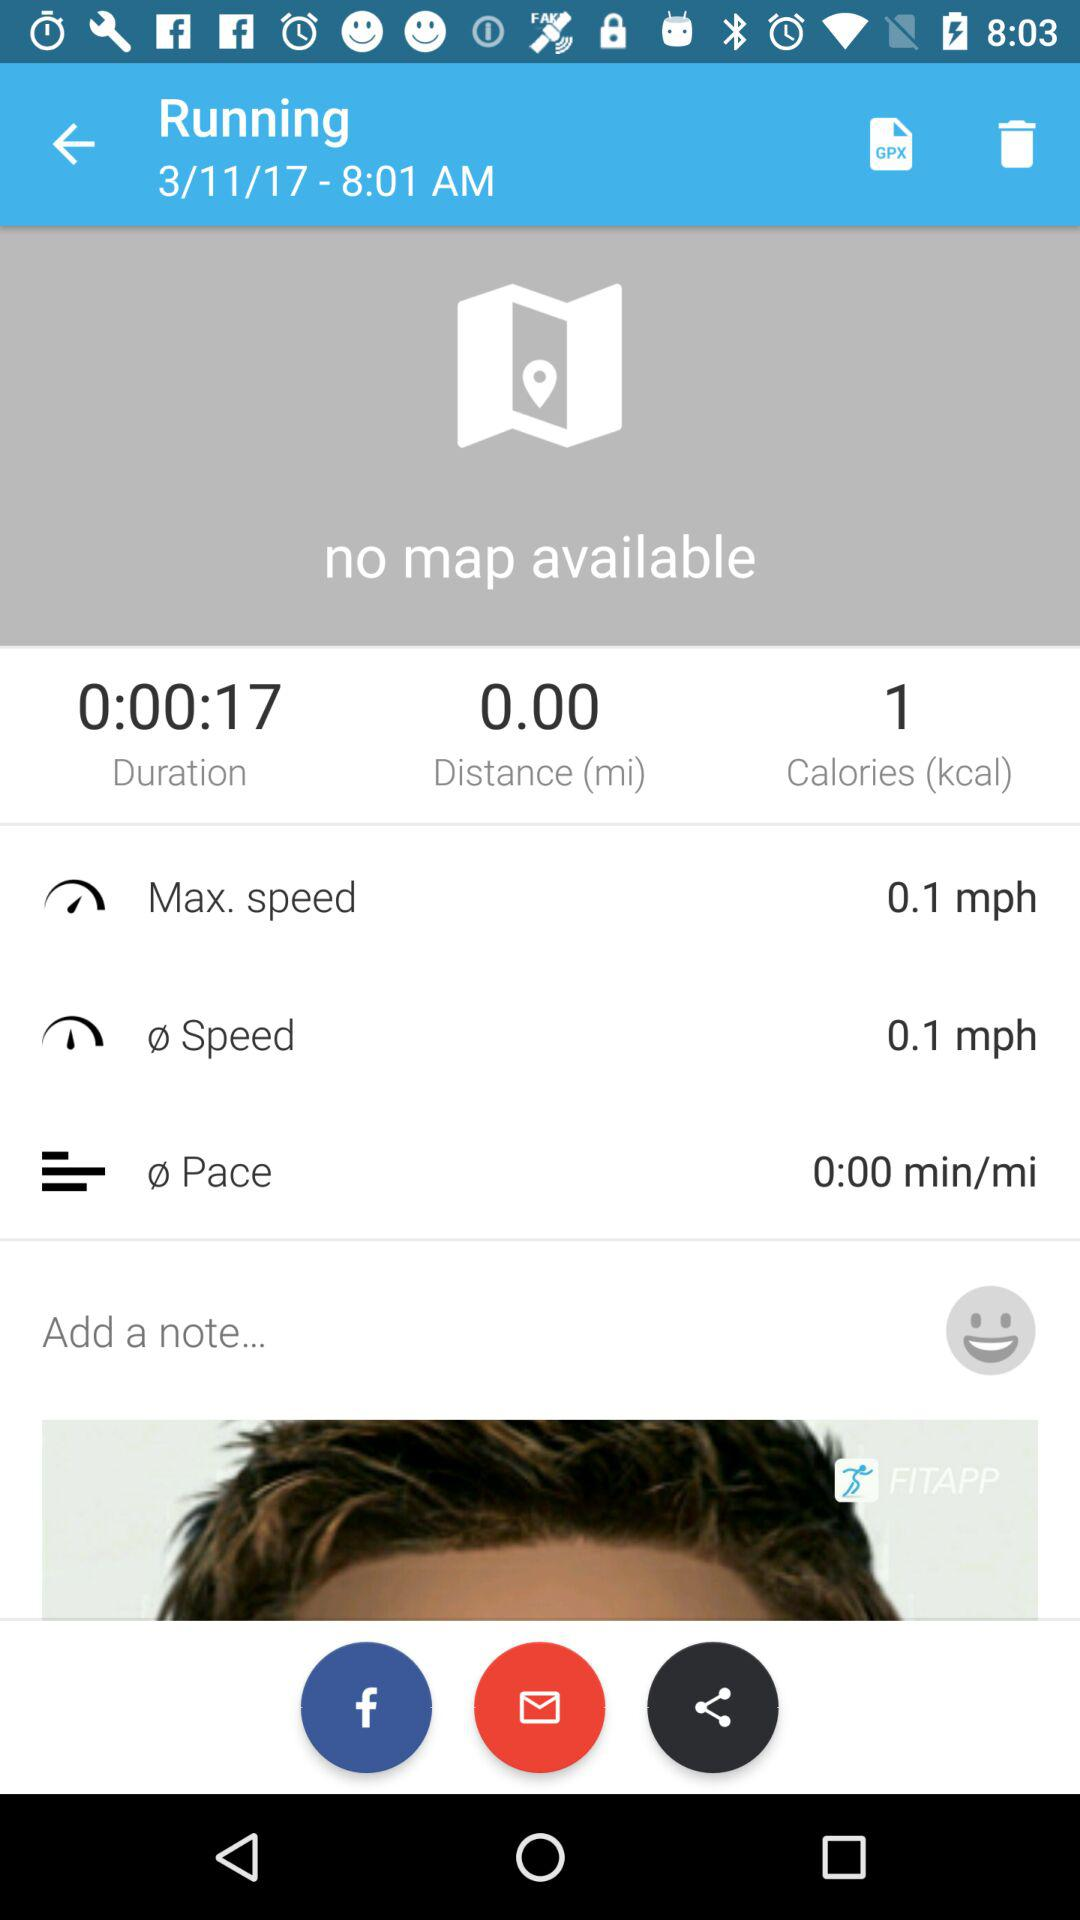What is the date and time? The date is March 11, 2017 and the time is 8:01 AM. 